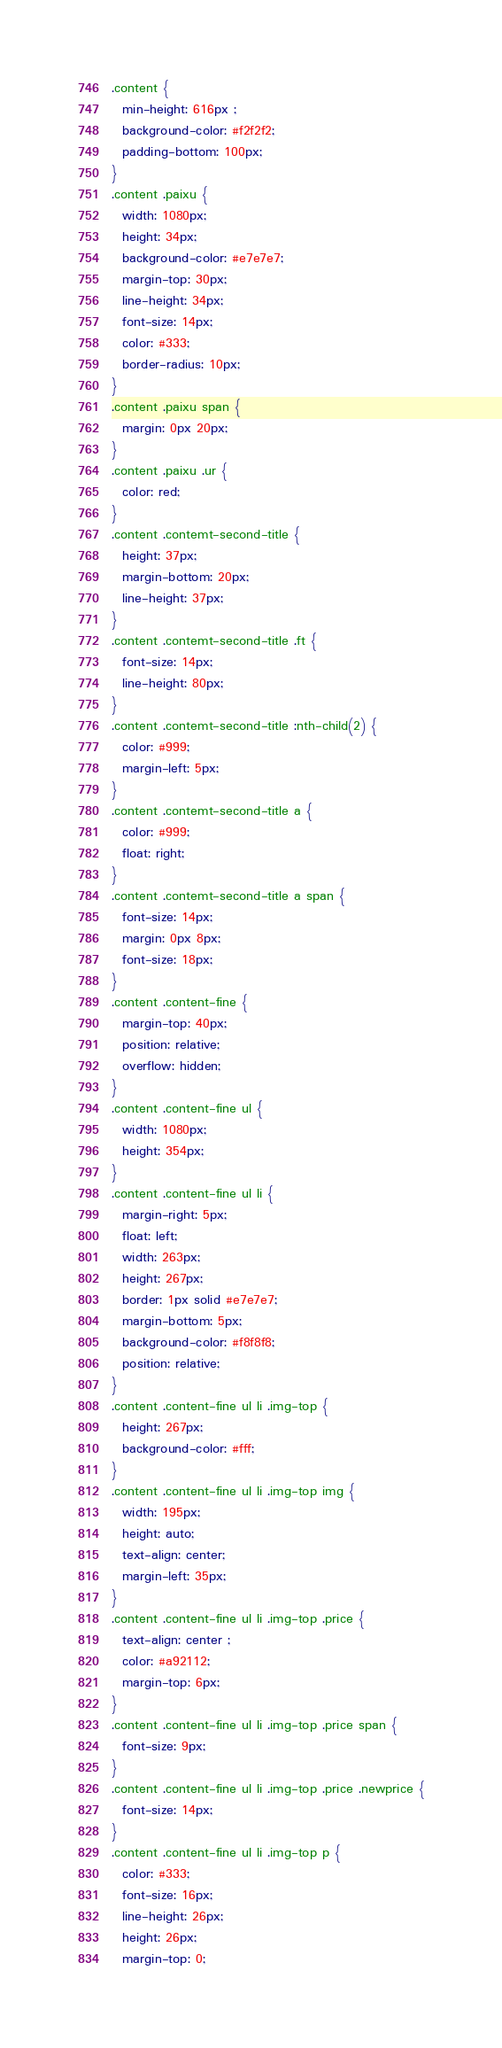<code> <loc_0><loc_0><loc_500><loc_500><_CSS_>.content {
  min-height: 616px ;
  background-color: #f2f2f2;
  padding-bottom: 100px;
}
.content .paixu {
  width: 1080px;
  height: 34px;
  background-color: #e7e7e7;
  margin-top: 30px;
  line-height: 34px;
  font-size: 14px;
  color: #333;
  border-radius: 10px;
}
.content .paixu span {
  margin: 0px 20px;
}
.content .paixu .ur {
  color: red;
}
.content .contemt-second-title {
  height: 37px;
  margin-bottom: 20px;
  line-height: 37px;
}
.content .contemt-second-title .ft {
  font-size: 14px;
  line-height: 80px;
}
.content .contemt-second-title :nth-child(2) {
  color: #999;
  margin-left: 5px;
}
.content .contemt-second-title a {
  color: #999;
  float: right;
}
.content .contemt-second-title a span {
  font-size: 14px;
  margin: 0px 8px;
  font-size: 18px;
}
.content .content-fine {
  margin-top: 40px;
  position: relative;
  overflow: hidden;
}
.content .content-fine ul {
  width: 1080px;
  height: 354px;
}
.content .content-fine ul li {
  margin-right: 5px;
  float: left;
  width: 263px;
  height: 267px;
  border: 1px solid #e7e7e7;
  margin-bottom: 5px;
  background-color: #f8f8f8;
  position: relative;
}
.content .content-fine ul li .img-top {
  height: 267px;
  background-color: #fff;
}
.content .content-fine ul li .img-top img {
  width: 195px;
  height: auto;
  text-align: center;
  margin-left: 35px;
}
.content .content-fine ul li .img-top .price {
  text-align: center ;
  color: #a92112;
  margin-top: 6px;
}
.content .content-fine ul li .img-top .price span {
  font-size: 9px;
}
.content .content-fine ul li .img-top .price .newprice {
  font-size: 14px;
}
.content .content-fine ul li .img-top p {
  color: #333;
  font-size: 16px;
  line-height: 26px;
  height: 26px;
  margin-top: 0;</code> 